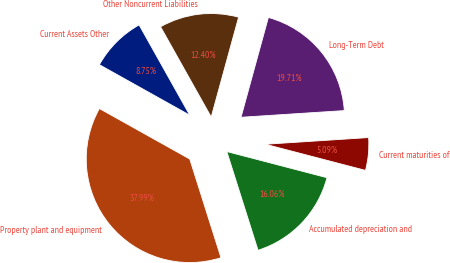<chart> <loc_0><loc_0><loc_500><loc_500><pie_chart><fcel>Current Assets Other<fcel>Property plant and equipment<fcel>Accumulated depreciation and<fcel>Current maturities of<fcel>Long-Term Debt<fcel>Other Noncurrent Liabilities<nl><fcel>8.75%<fcel>37.99%<fcel>16.06%<fcel>5.09%<fcel>19.71%<fcel>12.4%<nl></chart> 